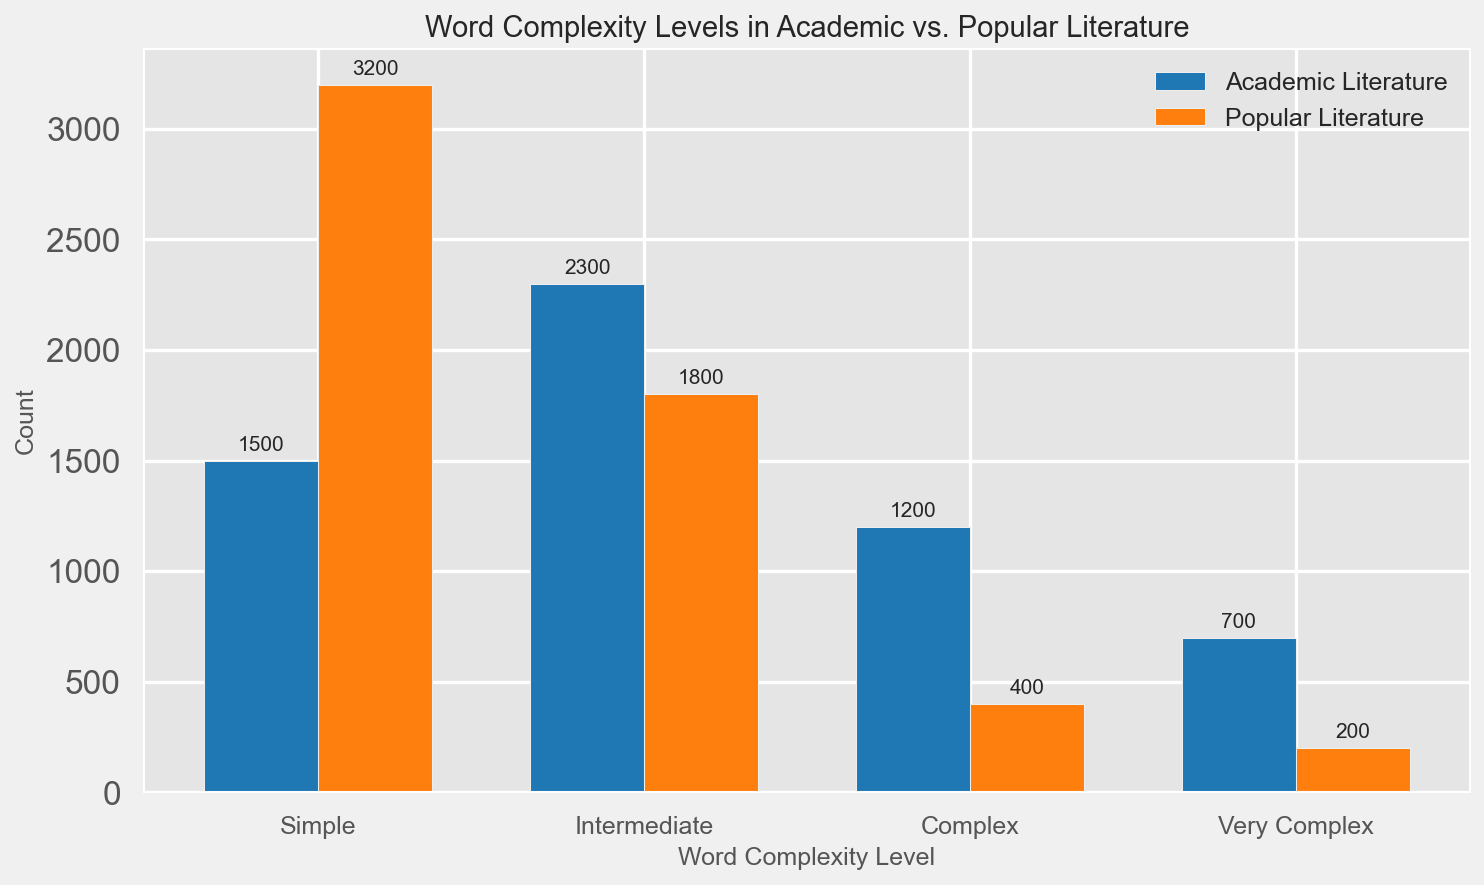What is the total number of words categorized as "Simple" in both Academic and Popular Literature? To find the total number, sum the counts for "Simple" words in Academic Literature (1500) and Popular Literature (3200). The total is 1500 + 3200 = 4700.
Answer: 4700 Which category has more "Complex" words, and by how much? Compare the counts for "Complex" words in Academic Literature (1200) and Popular Literature (400). The difference is 1200 - 400 = 800. Academic Literature has more "Complex" words by 800.
Answer: Academic Literature by 800 How does the count of "Intermediate" words in Popular Literature compare to "Simple" words in Academic Literature? Compare the counts for "Intermediate" words in Popular Literature (1800) and "Simple" words in Academic Literature (1500). "Intermediate" words in Popular Literature are 1800 - 1500 = 300 more than "Simple" words in Academic Literature.
Answer: Popular Literature by 300 Which category has the highest number of words categorized as "Very Complex"? The counts for "Very Complex" words are 700 for Academic Literature and 200 for Popular Literature. Hence, Academic Literature has the highest number of "Very Complex" words.
Answer: Academic Literature What is the difference in the count of "Intermediate" words between Academic and Popular Literature? Subtract the count of "Intermediate" words in Popular Literature (1800) from the count in Academic Literature (2300). The difference is 2300 - 1800 = 500.
Answer: 500 Which Word Complexity Level has the greatest disparity in count between Academic and Popular Literature, and what is that disparity? Calculate the absolute differences for each Word Complexity Level: Simple (3200-1500=1700), Intermediate (2300-1800=500), Complex (1200-400=800), Very Complex (700-200=500). The greatest disparity is for "Simple" words with a difference of 1700.
Answer: Simple, 1700 What is the average count of "Very Complex" words across both categories? The counts for "Very Complex" words are 700 for Academic Literature and 200 for Popular Literature. Sum these (700 + 200) and divide by 2 to find the average: (700 + 200)/2 = 450.
Answer: 450 How many more "Simple" words are there in Popular Literature compared to "Very Complex" words in Academic Literature? Subtract the count of "Very Complex" words in Academic Literature (700) from the count of "Simple" words in Popular Literature (3200). The difference is 3200 - 700 = 2500.
Answer: 2500 